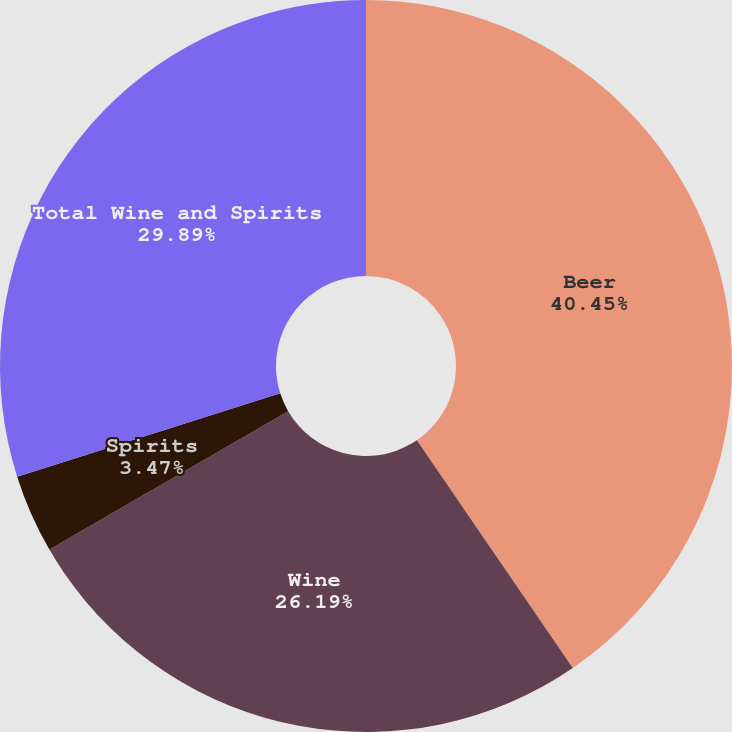Convert chart. <chart><loc_0><loc_0><loc_500><loc_500><pie_chart><fcel>Beer<fcel>Wine<fcel>Spirits<fcel>Total Wine and Spirits<nl><fcel>40.44%<fcel>26.19%<fcel>3.47%<fcel>29.89%<nl></chart> 